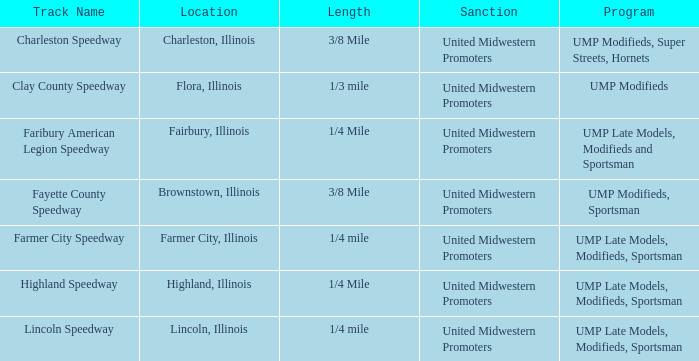Who granted permission for the event in lincoln, illinois? United Midwestern Promoters. 